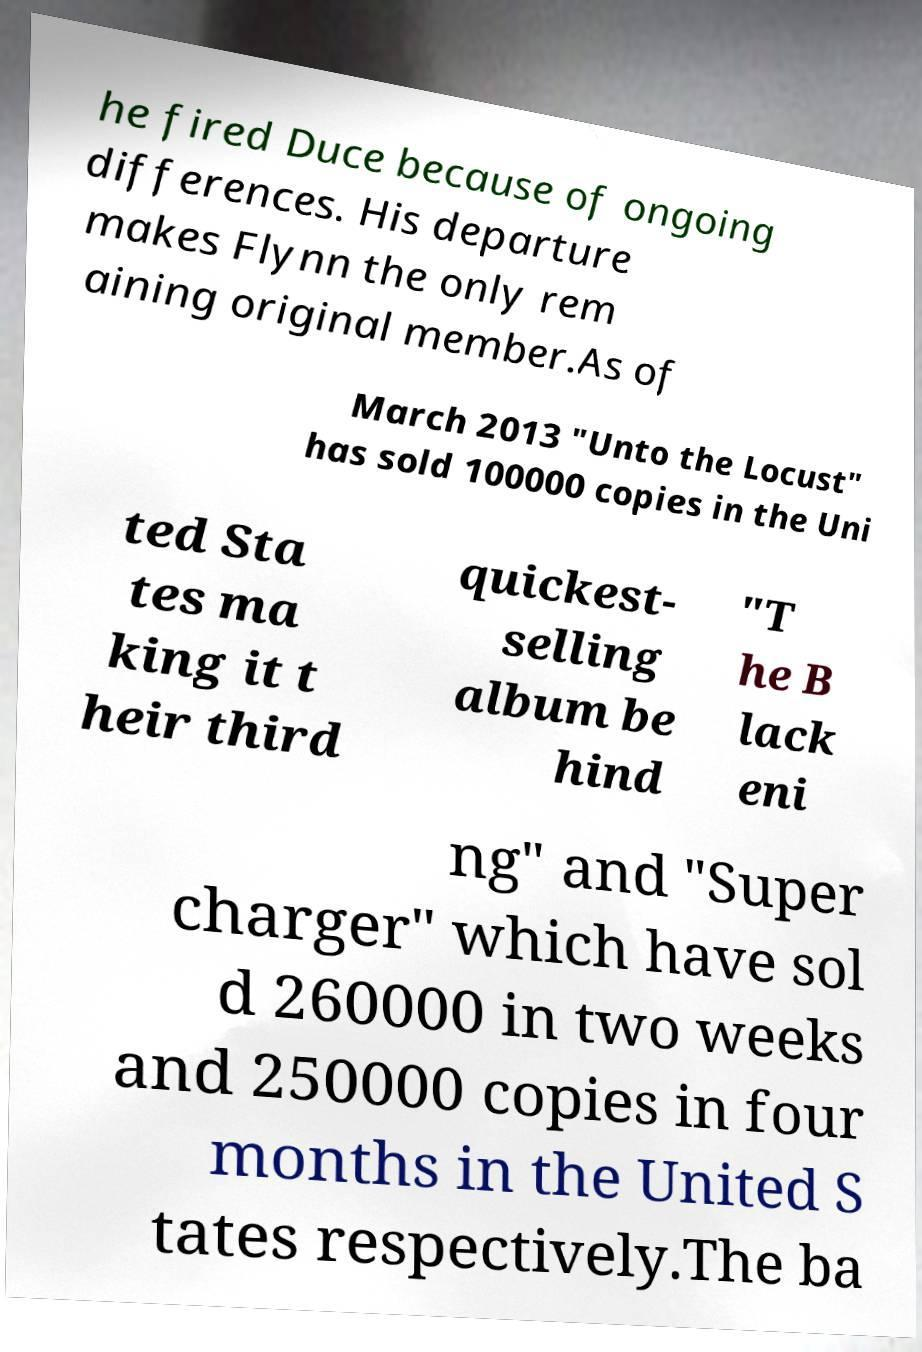I need the written content from this picture converted into text. Can you do that? he fired Duce because of ongoing differences. His departure makes Flynn the only rem aining original member.As of March 2013 "Unto the Locust" has sold 100000 copies in the Uni ted Sta tes ma king it t heir third quickest- selling album be hind "T he B lack eni ng" and "Super charger" which have sol d 260000 in two weeks and 250000 copies in four months in the United S tates respectively.The ba 